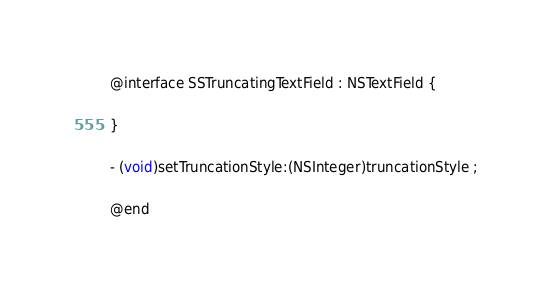<code> <loc_0><loc_0><loc_500><loc_500><_C_>@interface SSTruncatingTextField : NSTextField {

}

- (void)setTruncationStyle:(NSInteger)truncationStyle ;

@end
</code> 